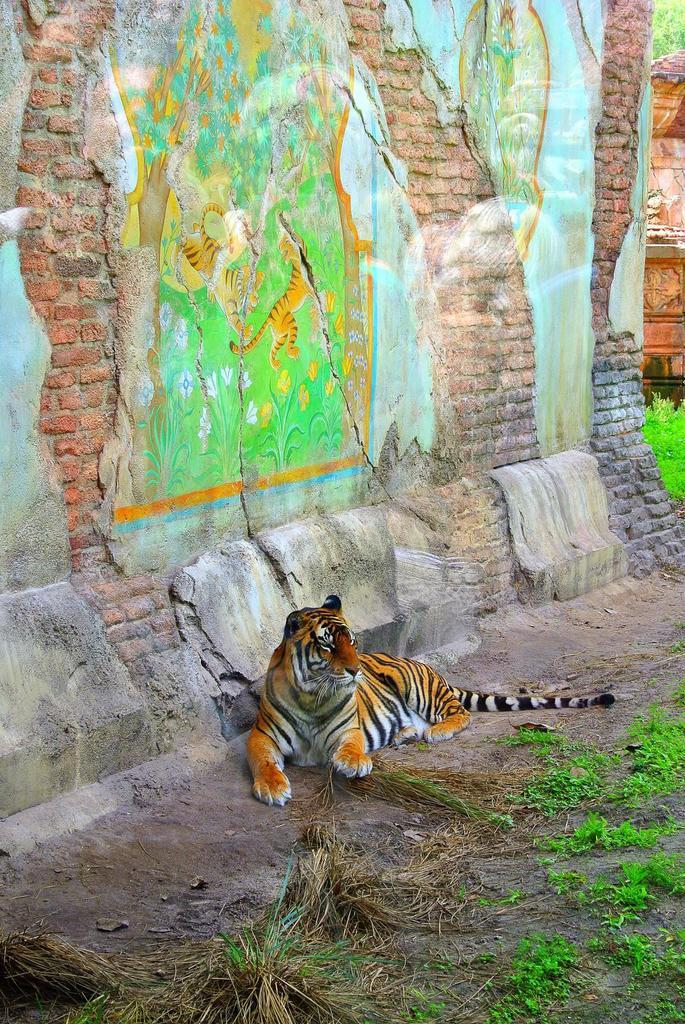What type of animal is in the image? There is a tiger in the image. What is the tiger doing in the image? The tiger is sitting. What can be seen behind the tiger in the image? There is a brick wall in the image. What type of vegetation is present in the image? Grass is present on the land in the image. What time of day is depicted in the image, according to the hour? The image does not provide any information about the time of day, so it is not possible to determine the hour. 